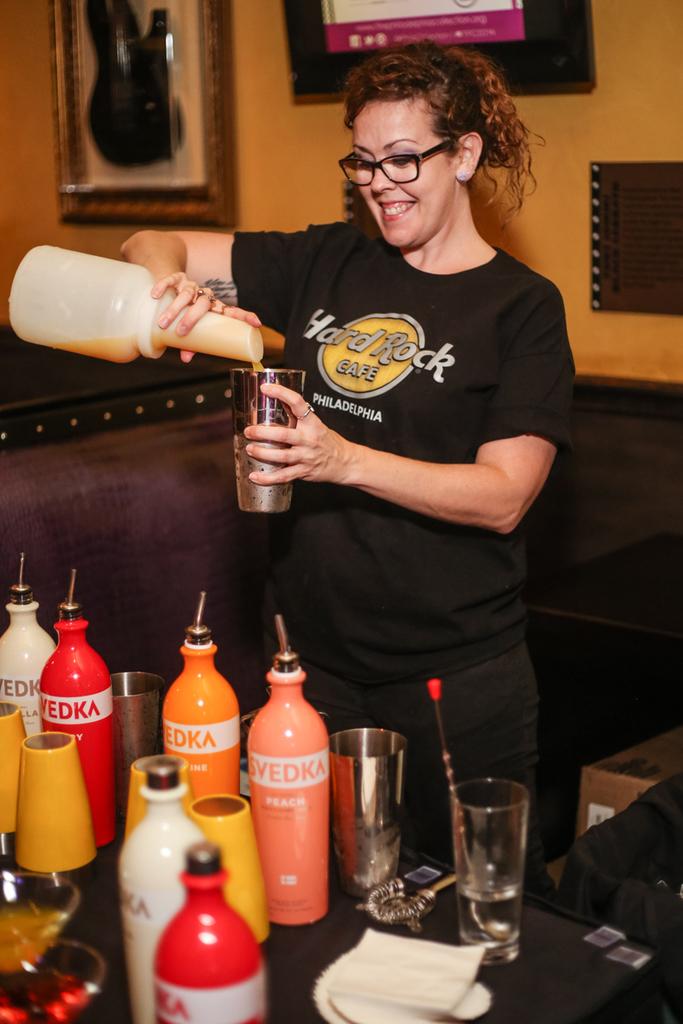What city is written on the lady's t-shirt?
Your response must be concise. Philadelphia. What kind of cafe are they at?
Ensure brevity in your answer.  Hard rock. 